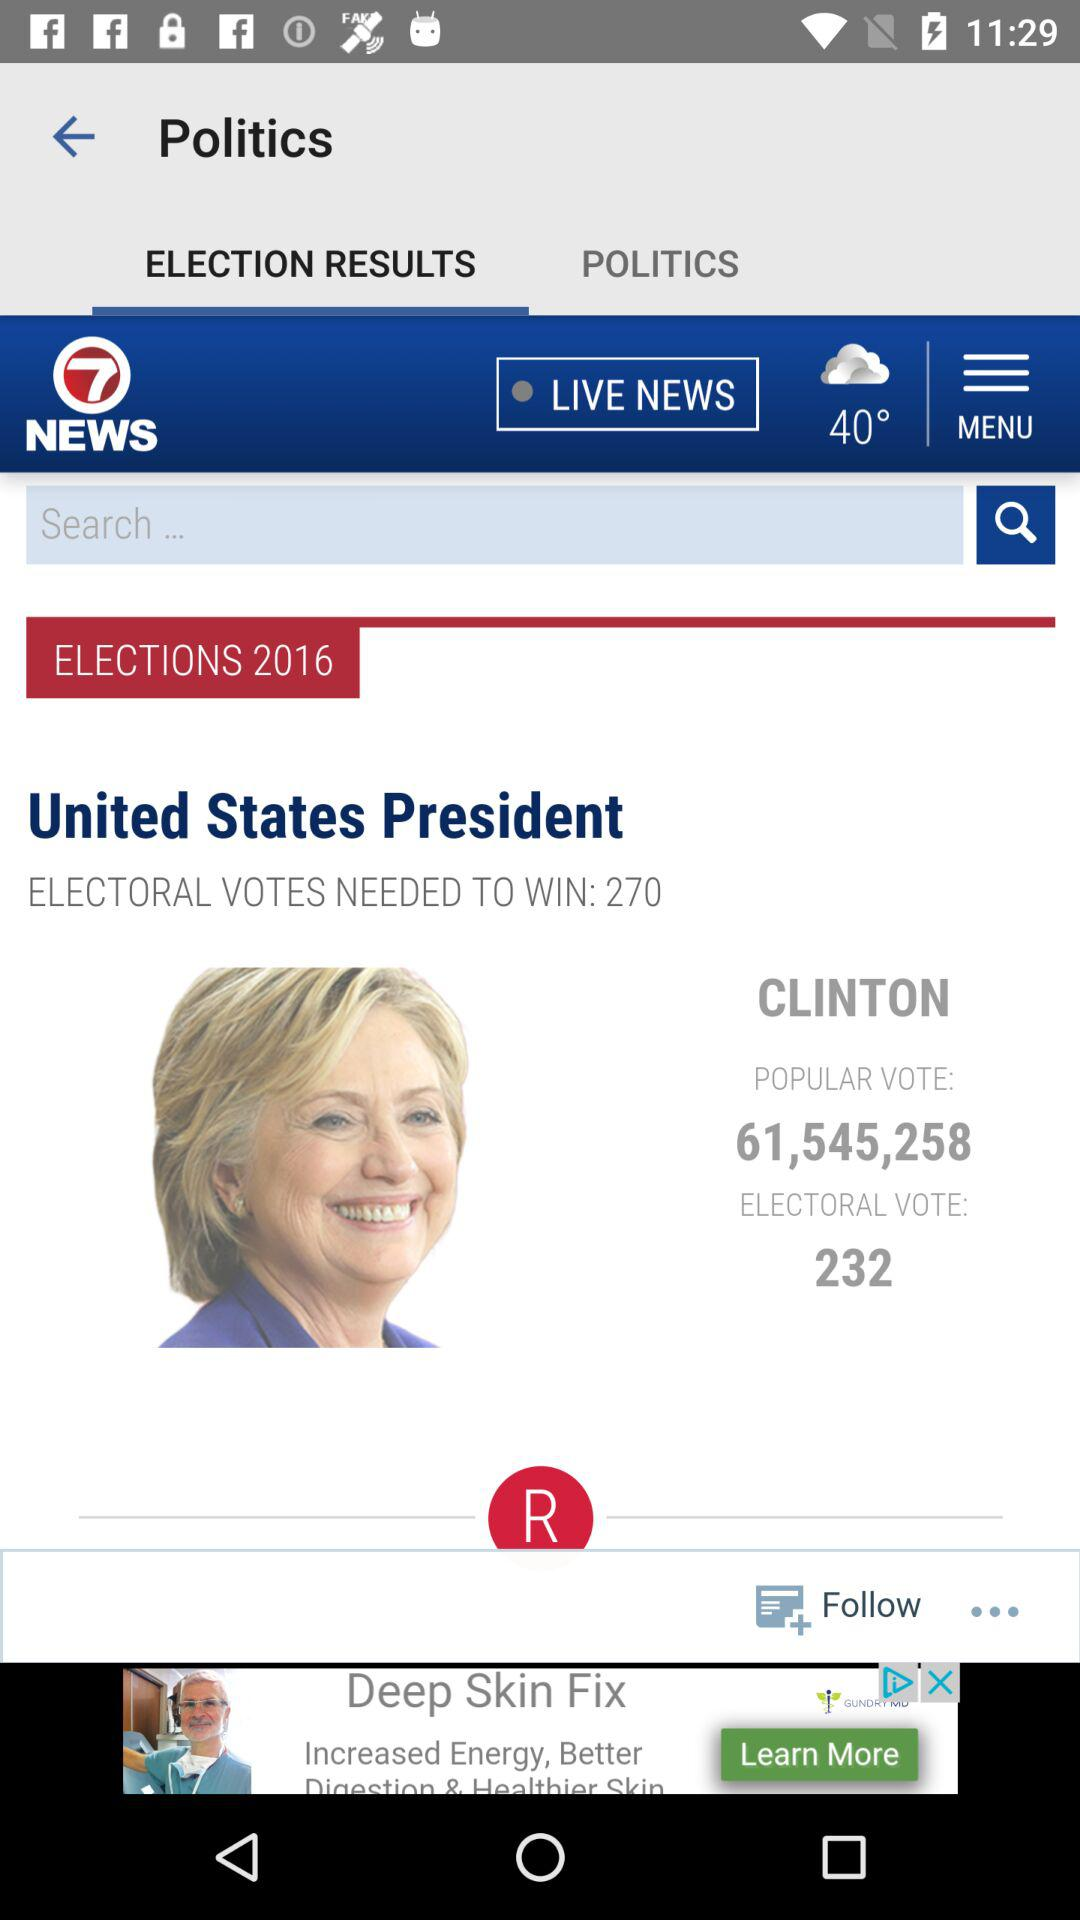How many popular votes did Clinton receive? Clinton received 61,545,258 popular votes. 